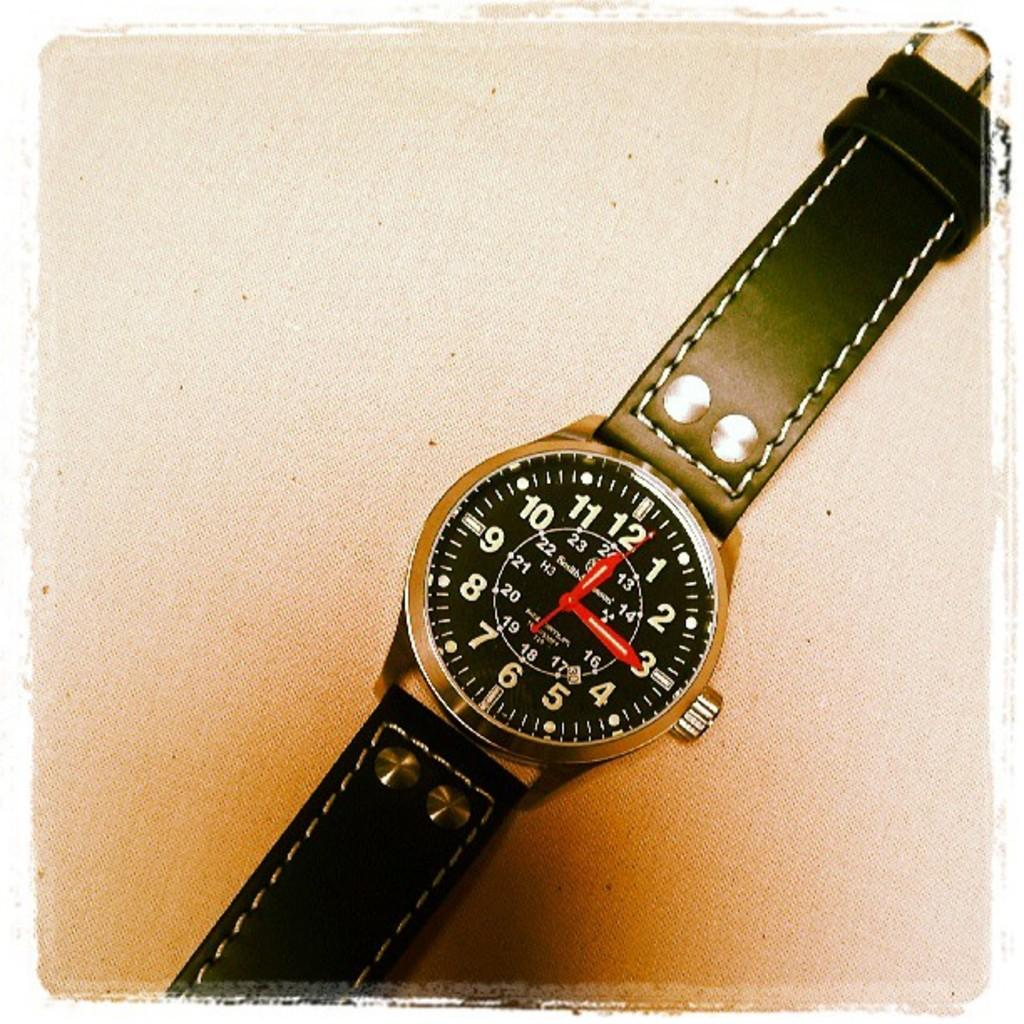<image>
Relay a brief, clear account of the picture shown. Black wristwatch which has the hands on the number 12 and 3. 